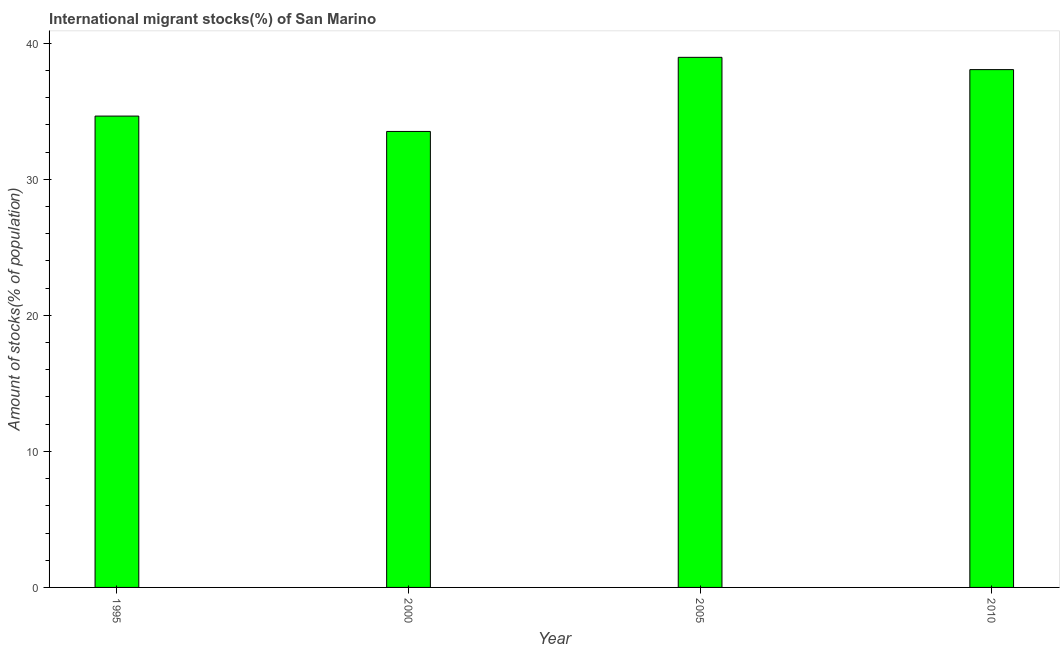Does the graph contain any zero values?
Keep it short and to the point. No. What is the title of the graph?
Your answer should be very brief. International migrant stocks(%) of San Marino. What is the label or title of the Y-axis?
Keep it short and to the point. Amount of stocks(% of population). What is the number of international migrant stocks in 2005?
Give a very brief answer. 38.97. Across all years, what is the maximum number of international migrant stocks?
Make the answer very short. 38.97. Across all years, what is the minimum number of international migrant stocks?
Your answer should be compact. 33.52. In which year was the number of international migrant stocks maximum?
Make the answer very short. 2005. In which year was the number of international migrant stocks minimum?
Provide a succinct answer. 2000. What is the sum of the number of international migrant stocks?
Give a very brief answer. 145.21. What is the difference between the number of international migrant stocks in 1995 and 2010?
Offer a terse response. -3.42. What is the average number of international migrant stocks per year?
Make the answer very short. 36.3. What is the median number of international migrant stocks?
Make the answer very short. 36.36. In how many years, is the number of international migrant stocks greater than 8 %?
Offer a terse response. 4. What is the ratio of the number of international migrant stocks in 2000 to that in 2005?
Give a very brief answer. 0.86. Is the number of international migrant stocks in 1995 less than that in 2005?
Give a very brief answer. Yes. What is the difference between the highest and the second highest number of international migrant stocks?
Give a very brief answer. 0.9. Is the sum of the number of international migrant stocks in 1995 and 2000 greater than the maximum number of international migrant stocks across all years?
Ensure brevity in your answer.  Yes. What is the difference between the highest and the lowest number of international migrant stocks?
Provide a short and direct response. 5.45. How many years are there in the graph?
Give a very brief answer. 4. What is the difference between two consecutive major ticks on the Y-axis?
Provide a short and direct response. 10. Are the values on the major ticks of Y-axis written in scientific E-notation?
Your answer should be compact. No. What is the Amount of stocks(% of population) of 1995?
Your answer should be very brief. 34.65. What is the Amount of stocks(% of population) of 2000?
Provide a short and direct response. 33.52. What is the Amount of stocks(% of population) of 2005?
Give a very brief answer. 38.97. What is the Amount of stocks(% of population) of 2010?
Your answer should be very brief. 38.07. What is the difference between the Amount of stocks(% of population) in 1995 and 2000?
Your answer should be very brief. 1.13. What is the difference between the Amount of stocks(% of population) in 1995 and 2005?
Provide a succinct answer. -4.32. What is the difference between the Amount of stocks(% of population) in 1995 and 2010?
Offer a very short reply. -3.42. What is the difference between the Amount of stocks(% of population) in 2000 and 2005?
Your answer should be compact. -5.45. What is the difference between the Amount of stocks(% of population) in 2000 and 2010?
Offer a very short reply. -4.54. What is the difference between the Amount of stocks(% of population) in 2005 and 2010?
Ensure brevity in your answer.  0.9. What is the ratio of the Amount of stocks(% of population) in 1995 to that in 2000?
Offer a terse response. 1.03. What is the ratio of the Amount of stocks(% of population) in 1995 to that in 2005?
Provide a short and direct response. 0.89. What is the ratio of the Amount of stocks(% of population) in 1995 to that in 2010?
Your answer should be very brief. 0.91. What is the ratio of the Amount of stocks(% of population) in 2000 to that in 2005?
Keep it short and to the point. 0.86. What is the ratio of the Amount of stocks(% of population) in 2000 to that in 2010?
Give a very brief answer. 0.88. What is the ratio of the Amount of stocks(% of population) in 2005 to that in 2010?
Your answer should be very brief. 1.02. 